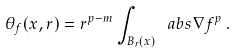<formula> <loc_0><loc_0><loc_500><loc_500>\theta _ { f } ( x , r ) = r ^ { p - m } \int _ { B _ { r } ( x ) } \ a b s { \nabla f } ^ { p } \, .</formula> 